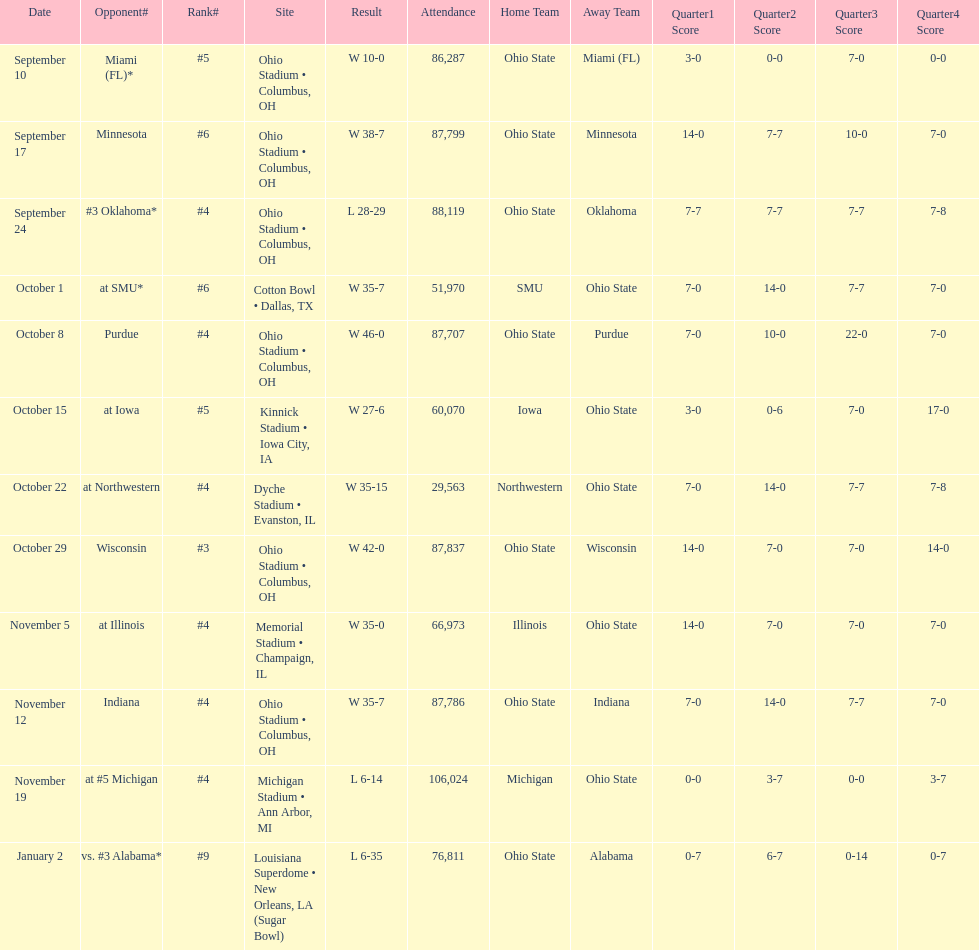What was the final game with an attendance below 30,000 people? October 22. 